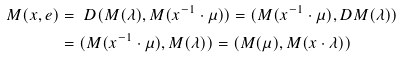<formula> <loc_0><loc_0><loc_500><loc_500>M ( x , e ) & = \ D ( M ( \lambda ) , M ( x ^ { - 1 } \cdot \mu ) ) = \L ( M ( x ^ { - 1 } \cdot \mu ) , D M ( \lambda ) ) \\ & = \L ( M ( x ^ { - 1 } \cdot \mu ) , M ( \lambda ) ) = \L ( M ( \mu ) , M ( x \cdot \lambda ) )</formula> 